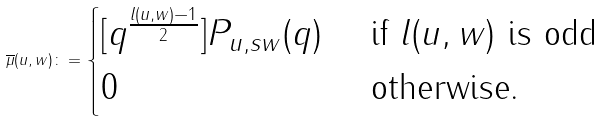Convert formula to latex. <formula><loc_0><loc_0><loc_500><loc_500>\overline { \mu } ( u , w ) \colon = \begin{cases} [ q ^ { \frac { l ( u , w ) - 1 } { 2 } } ] P _ { u , s w } ( q ) & \text { if } l ( u , w ) \text { is odd } \\ 0 & \text { otherwise. } \end{cases}</formula> 